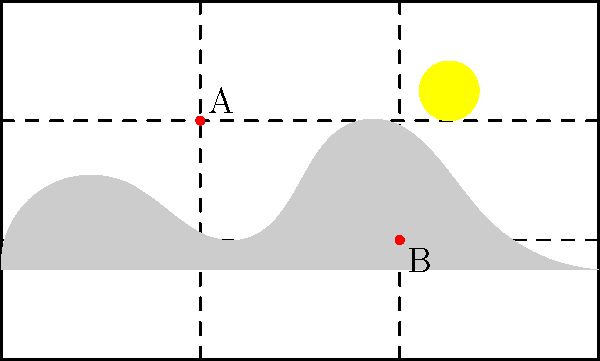In the landscape image above, which utilizes the rule of thirds grid overlay, points A and B are positioned at intersections of the grid lines. If the image has a width of 3000 pixels, what is the horizontal distance in pixels between points A and B? To solve this problem, we'll follow these steps:

1. Understand the rule of thirds grid:
   The rule of thirds divides the image into a 3x3 grid, creating 9 equal rectangles.

2. Identify the positions of points A and B:
   Point A is at the left-top intersection of the grid lines.
   Point B is at the right-bottom intersection of the grid lines.

3. Calculate the relative positions:
   In the rule of thirds, the grid lines are at 1/3 and 2/3 of the image's dimensions.
   Point A is at 1/3 of the width from the left.
   Point B is at 2/3 of the width from the left.

4. Calculate the distance between A and B:
   The distance is the difference between their positions: 2/3 - 1/3 = 1/3 of the total width.

5. Convert to pixels:
   Given width = 3000 pixels
   Distance = 1/3 * 3000 = 1000 pixels

Therefore, the horizontal distance between points A and B is 1000 pixels.
Answer: 1000 pixels 